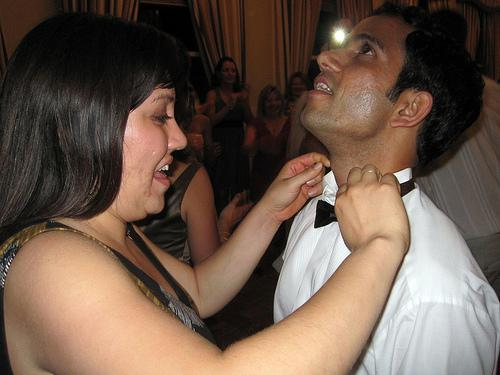Question: what color is the man's bowtie?
Choices:
A. Black.
B. Red.
C. Brown.
D. Blue.
Answer with the letter. Answer: A Question: who is wearing the bowtie?
Choices:
A. A woman.
B. The old men.
C. A man.
D. The little kids.
Answer with the letter. Answer: C Question: who it's fixing the man's bow tie?
Choices:
A. A girl.
B. Another man.
C. His dad.
D. A woman.
Answer with the letter. Answer: D Question: how many bowties are in the picture?
Choices:
A. 3.
B. 4.
C. 1.
D. 2.
Answer with the letter. Answer: C Question: what color hair does the woman fixing the bowtie have?
Choices:
A. Black.
B. Brown.
C. Grey.
D. Red.
Answer with the letter. Answer: A Question: what color of shirt is the man with the bow tie wearing?
Choices:
A. Red.
B. White.
C. Blue.
D. Green.
Answer with the letter. Answer: B 